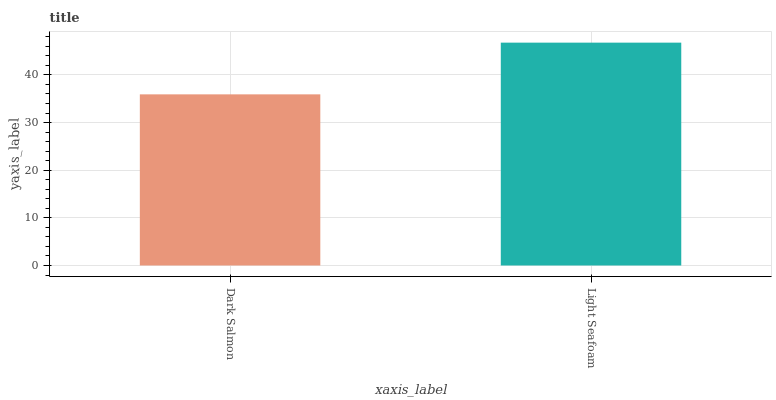Is Dark Salmon the minimum?
Answer yes or no. Yes. Is Light Seafoam the maximum?
Answer yes or no. Yes. Is Light Seafoam the minimum?
Answer yes or no. No. Is Light Seafoam greater than Dark Salmon?
Answer yes or no. Yes. Is Dark Salmon less than Light Seafoam?
Answer yes or no. Yes. Is Dark Salmon greater than Light Seafoam?
Answer yes or no. No. Is Light Seafoam less than Dark Salmon?
Answer yes or no. No. Is Light Seafoam the high median?
Answer yes or no. Yes. Is Dark Salmon the low median?
Answer yes or no. Yes. Is Dark Salmon the high median?
Answer yes or no. No. Is Light Seafoam the low median?
Answer yes or no. No. 